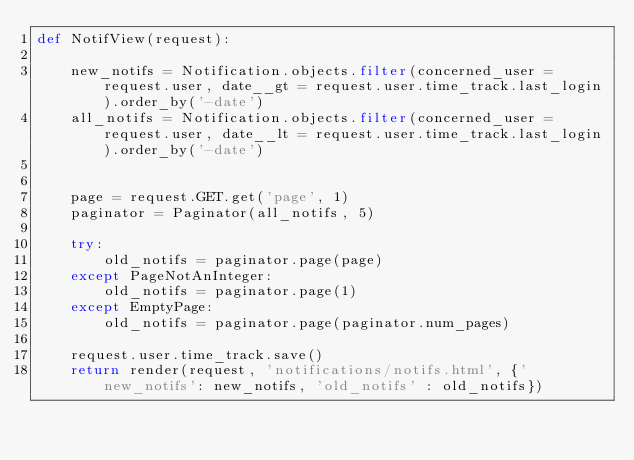Convert code to text. <code><loc_0><loc_0><loc_500><loc_500><_Python_>def NotifView(request):

    new_notifs = Notification.objects.filter(concerned_user = request.user, date__gt = request.user.time_track.last_login).order_by('-date')
    all_notifs = Notification.objects.filter(concerned_user = request.user, date__lt = request.user.time_track.last_login).order_by('-date')
    
    
    page = request.GET.get('page', 1)
    paginator = Paginator(all_notifs, 5)    
    
    try:
        old_notifs = paginator.page(page)
    except PageNotAnInteger:
        old_notifs = paginator.page(1)
    except EmptyPage:
        old_notifs = paginator.page(paginator.num_pages)

    request.user.time_track.save()
    return render(request, 'notifications/notifs.html', {'new_notifs': new_notifs, 'old_notifs' : old_notifs})

</code> 